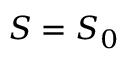<formula> <loc_0><loc_0><loc_500><loc_500>{ S = S _ { 0 } }</formula> 